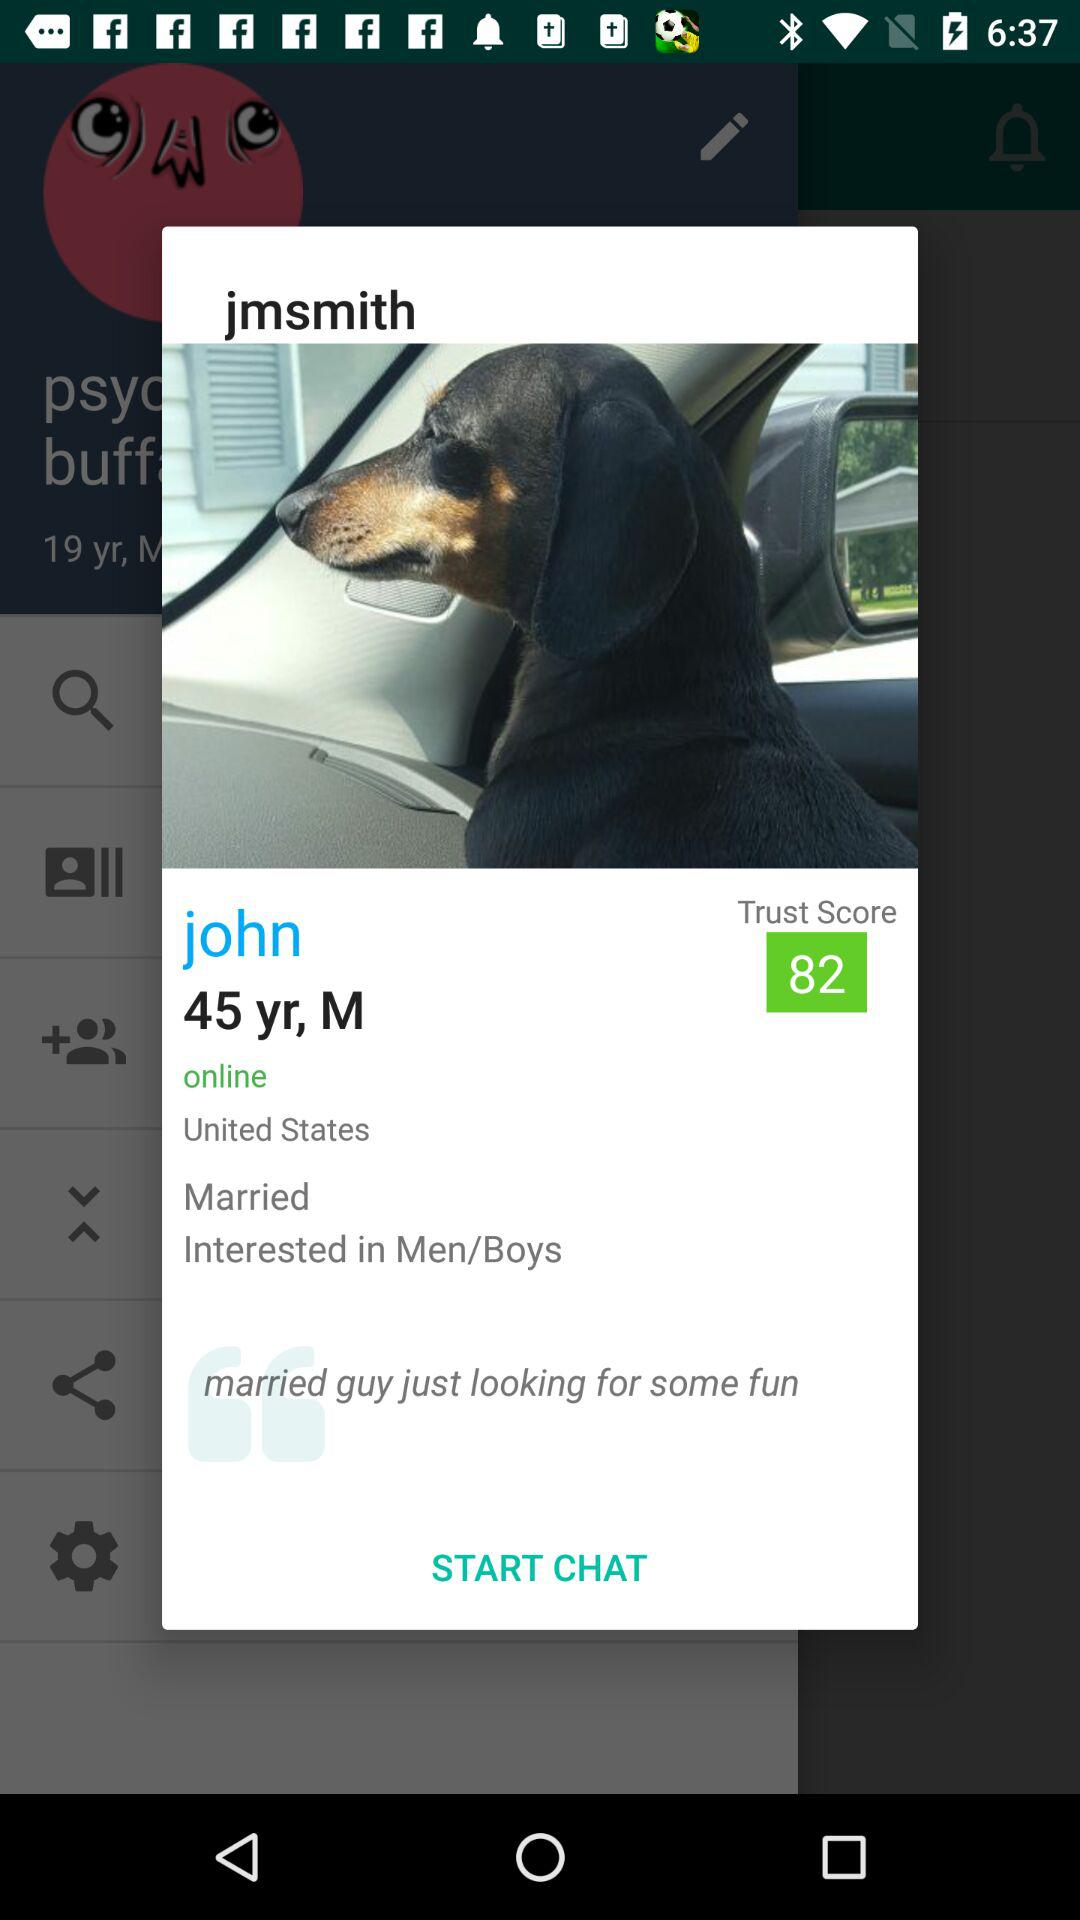What is the age of John? The age is 45 years. 